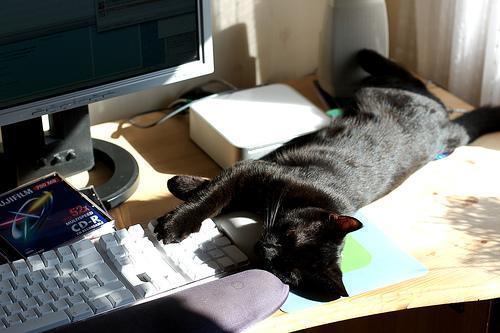How many cats are in the picture?
Give a very brief answer. 1. 